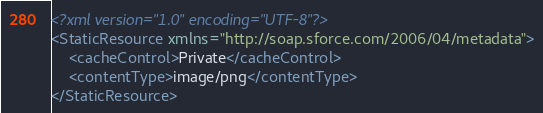Convert code to text. <code><loc_0><loc_0><loc_500><loc_500><_XML_><?xml version="1.0" encoding="UTF-8"?>
<StaticResource xmlns="http://soap.sforce.com/2006/04/metadata">
    <cacheControl>Private</cacheControl>
    <contentType>image/png</contentType>
</StaticResource>
</code> 